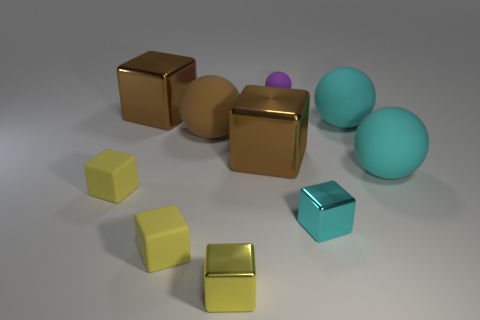Is the large cube that is in front of the brown ball made of the same material as the small purple thing?
Offer a terse response. No. There is a yellow metal thing in front of the tiny cube right of the purple ball; what number of big brown blocks are to the left of it?
Ensure brevity in your answer.  1. There is a big rubber thing on the left side of the small purple object; is it the same shape as the purple matte thing?
Provide a succinct answer. Yes. How many objects are big rubber balls or large rubber spheres that are on the right side of the small purple matte ball?
Give a very brief answer. 3. Are there more rubber things that are to the right of the purple ball than brown balls?
Provide a succinct answer. Yes. Is the number of large cyan things that are left of the brown rubber ball the same as the number of metallic objects that are on the right side of the tiny cyan shiny thing?
Offer a terse response. Yes. Is there a brown metallic thing in front of the brown cube on the left side of the brown ball?
Your answer should be very brief. Yes. What is the shape of the yellow metal object?
Your answer should be very brief. Cube. How big is the yellow rubber cube on the right side of the large brown object behind the brown rubber ball?
Your answer should be compact. Small. What size is the purple sphere that is to the right of the brown matte ball?
Ensure brevity in your answer.  Small. 